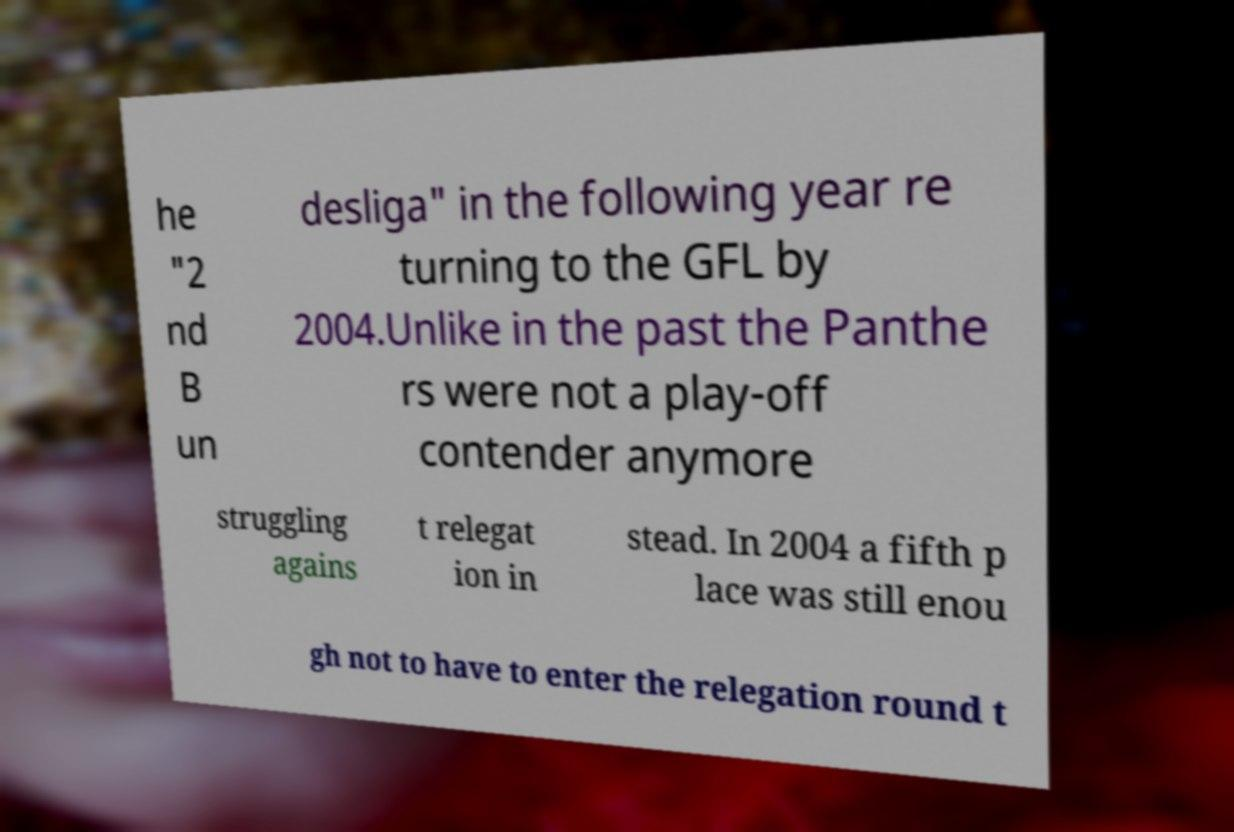I need the written content from this picture converted into text. Can you do that? he "2 nd B un desliga" in the following year re turning to the GFL by 2004.Unlike in the past the Panthe rs were not a play-off contender anymore struggling agains t relegat ion in stead. In 2004 a fifth p lace was still enou gh not to have to enter the relegation round t 